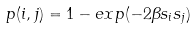Convert formula to latex. <formula><loc_0><loc_0><loc_500><loc_500>p ( i , j ) = 1 - e x p ( - 2 { \beta } { s _ { i } } { s _ { j } } )</formula> 